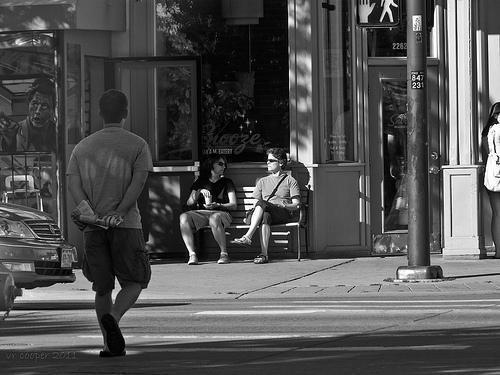How many cars are there?
Give a very brief answer. 1. How many people are sitting down?
Give a very brief answer. 2. 